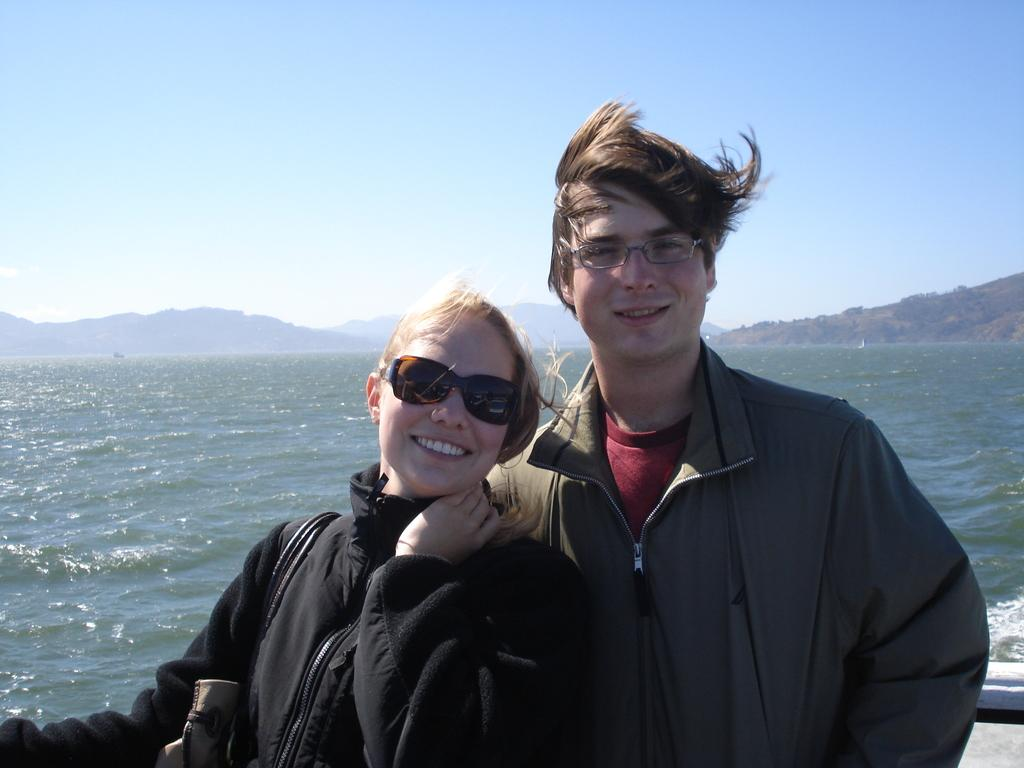How many people are present in the image? There is a man and a woman in the image. What can be seen in the background of the image? Water, hills, and the sky are visible in the background of the image. Can you describe the setting of the image? The image appears to be set near water, with hills and the sky visible in the background. What type of watch is the man wearing in the image? There is no watch visible on the man in the image. What is the man cooking on the stove in the image? There is no stove present in the image; it features a man and a woman near water with hills and the sky in the background. 